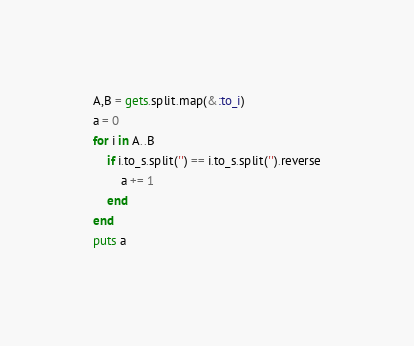Convert code to text. <code><loc_0><loc_0><loc_500><loc_500><_Ruby_>A,B = gets.split.map(&:to_i)
a = 0
for i in A..B
    if i.to_s.split('') == i.to_s.split('').reverse
        a += 1
    end
end
puts a
</code> 